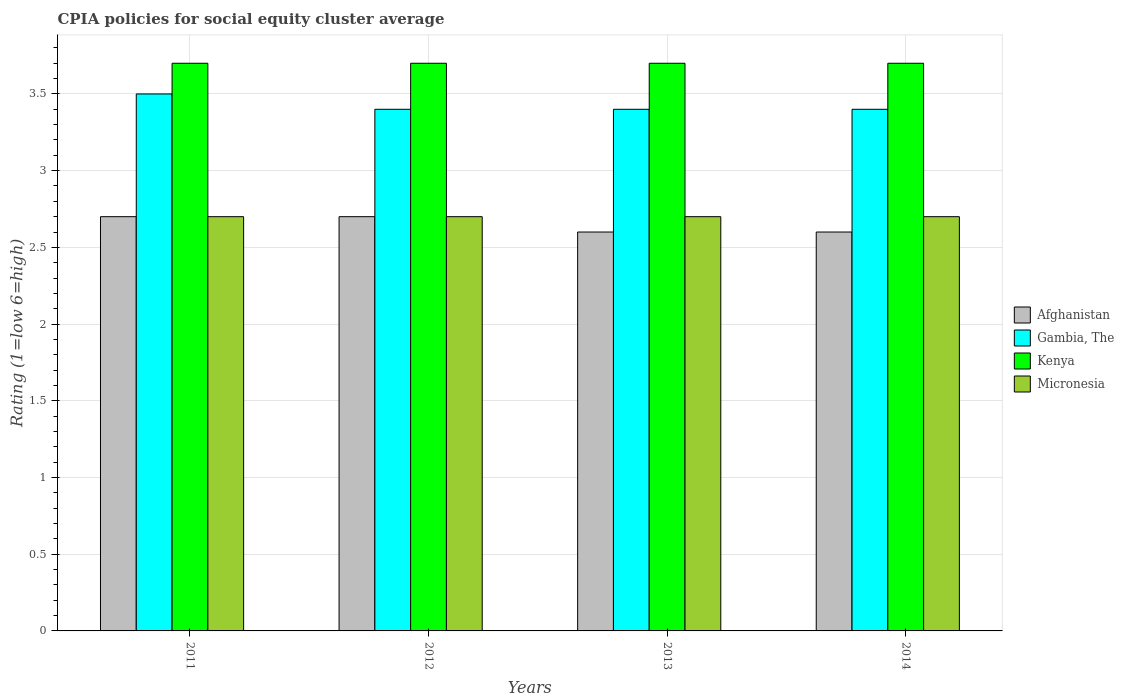How many different coloured bars are there?
Give a very brief answer. 4. How many groups of bars are there?
Provide a short and direct response. 4. How many bars are there on the 2nd tick from the left?
Ensure brevity in your answer.  4. In how many cases, is the number of bars for a given year not equal to the number of legend labels?
Provide a short and direct response. 0. Across all years, what is the maximum CPIA rating in Afghanistan?
Your response must be concise. 2.7. In which year was the CPIA rating in Micronesia maximum?
Provide a short and direct response. 2011. What is the difference between the CPIA rating in Kenya in 2012 and that in 2014?
Ensure brevity in your answer.  0. What is the difference between the CPIA rating in Micronesia in 2011 and the CPIA rating in Afghanistan in 2014?
Provide a succinct answer. 0.1. What is the average CPIA rating in Kenya per year?
Keep it short and to the point. 3.7. In the year 2011, what is the difference between the CPIA rating in Gambia, The and CPIA rating in Kenya?
Give a very brief answer. -0.2. Is the CPIA rating in Gambia, The in 2012 less than that in 2014?
Provide a succinct answer. No. Is the difference between the CPIA rating in Gambia, The in 2011 and 2013 greater than the difference between the CPIA rating in Kenya in 2011 and 2013?
Provide a short and direct response. Yes. What is the difference between the highest and the second highest CPIA rating in Kenya?
Provide a short and direct response. 0. What is the difference between the highest and the lowest CPIA rating in Gambia, The?
Offer a very short reply. 0.1. Is the sum of the CPIA rating in Afghanistan in 2012 and 2013 greater than the maximum CPIA rating in Micronesia across all years?
Your response must be concise. Yes. Is it the case that in every year, the sum of the CPIA rating in Kenya and CPIA rating in Gambia, The is greater than the sum of CPIA rating in Afghanistan and CPIA rating in Micronesia?
Your response must be concise. No. What does the 3rd bar from the left in 2011 represents?
Offer a very short reply. Kenya. What does the 2nd bar from the right in 2012 represents?
Offer a very short reply. Kenya. Is it the case that in every year, the sum of the CPIA rating in Afghanistan and CPIA rating in Gambia, The is greater than the CPIA rating in Kenya?
Provide a succinct answer. Yes. Are all the bars in the graph horizontal?
Give a very brief answer. No. How many years are there in the graph?
Give a very brief answer. 4. What is the difference between two consecutive major ticks on the Y-axis?
Keep it short and to the point. 0.5. Are the values on the major ticks of Y-axis written in scientific E-notation?
Make the answer very short. No. Does the graph contain any zero values?
Your answer should be compact. No. What is the title of the graph?
Provide a succinct answer. CPIA policies for social equity cluster average. Does "Ghana" appear as one of the legend labels in the graph?
Provide a short and direct response. No. What is the label or title of the X-axis?
Make the answer very short. Years. What is the label or title of the Y-axis?
Your answer should be very brief. Rating (1=low 6=high). What is the Rating (1=low 6=high) of Gambia, The in 2011?
Make the answer very short. 3.5. What is the Rating (1=low 6=high) in Kenya in 2011?
Your answer should be very brief. 3.7. What is the Rating (1=low 6=high) in Micronesia in 2011?
Provide a succinct answer. 2.7. What is the Rating (1=low 6=high) in Kenya in 2012?
Make the answer very short. 3.7. What is the Rating (1=low 6=high) of Afghanistan in 2013?
Make the answer very short. 2.6. What is the Rating (1=low 6=high) of Gambia, The in 2013?
Provide a succinct answer. 3.4. What is the Rating (1=low 6=high) of Kenya in 2013?
Provide a succinct answer. 3.7. What is the Rating (1=low 6=high) of Micronesia in 2013?
Provide a short and direct response. 2.7. What is the Rating (1=low 6=high) of Gambia, The in 2014?
Provide a short and direct response. 3.4. What is the Rating (1=low 6=high) of Micronesia in 2014?
Your answer should be compact. 2.7. Across all years, what is the maximum Rating (1=low 6=high) of Gambia, The?
Your response must be concise. 3.5. Across all years, what is the minimum Rating (1=low 6=high) in Gambia, The?
Ensure brevity in your answer.  3.4. Across all years, what is the minimum Rating (1=low 6=high) of Kenya?
Your response must be concise. 3.7. Across all years, what is the minimum Rating (1=low 6=high) in Micronesia?
Your answer should be very brief. 2.7. What is the total Rating (1=low 6=high) of Kenya in the graph?
Your answer should be very brief. 14.8. What is the total Rating (1=low 6=high) of Micronesia in the graph?
Your answer should be compact. 10.8. What is the difference between the Rating (1=low 6=high) in Afghanistan in 2011 and that in 2012?
Make the answer very short. 0. What is the difference between the Rating (1=low 6=high) of Afghanistan in 2011 and that in 2013?
Make the answer very short. 0.1. What is the difference between the Rating (1=low 6=high) in Gambia, The in 2011 and that in 2013?
Offer a terse response. 0.1. What is the difference between the Rating (1=low 6=high) of Afghanistan in 2011 and that in 2014?
Offer a terse response. 0.1. What is the difference between the Rating (1=low 6=high) of Gambia, The in 2011 and that in 2014?
Provide a short and direct response. 0.1. What is the difference between the Rating (1=low 6=high) in Gambia, The in 2012 and that in 2013?
Ensure brevity in your answer.  0. What is the difference between the Rating (1=low 6=high) in Kenya in 2012 and that in 2013?
Your answer should be compact. 0. What is the difference between the Rating (1=low 6=high) of Micronesia in 2012 and that in 2014?
Provide a succinct answer. 0. What is the difference between the Rating (1=low 6=high) of Gambia, The in 2013 and that in 2014?
Offer a very short reply. 0. What is the difference between the Rating (1=low 6=high) of Kenya in 2013 and that in 2014?
Offer a very short reply. 0. What is the difference between the Rating (1=low 6=high) of Micronesia in 2013 and that in 2014?
Offer a very short reply. 0. What is the difference between the Rating (1=low 6=high) in Afghanistan in 2011 and the Rating (1=low 6=high) in Kenya in 2012?
Provide a short and direct response. -1. What is the difference between the Rating (1=low 6=high) of Afghanistan in 2011 and the Rating (1=low 6=high) of Micronesia in 2012?
Ensure brevity in your answer.  0. What is the difference between the Rating (1=low 6=high) of Afghanistan in 2011 and the Rating (1=low 6=high) of Kenya in 2013?
Offer a terse response. -1. What is the difference between the Rating (1=low 6=high) in Afghanistan in 2011 and the Rating (1=low 6=high) in Micronesia in 2014?
Your answer should be very brief. 0. What is the difference between the Rating (1=low 6=high) in Afghanistan in 2012 and the Rating (1=low 6=high) in Gambia, The in 2013?
Give a very brief answer. -0.7. What is the difference between the Rating (1=low 6=high) in Afghanistan in 2012 and the Rating (1=low 6=high) in Micronesia in 2013?
Offer a very short reply. 0. What is the difference between the Rating (1=low 6=high) of Gambia, The in 2012 and the Rating (1=low 6=high) of Micronesia in 2013?
Your answer should be very brief. 0.7. What is the difference between the Rating (1=low 6=high) in Kenya in 2012 and the Rating (1=low 6=high) in Micronesia in 2013?
Your answer should be very brief. 1. What is the difference between the Rating (1=low 6=high) in Afghanistan in 2012 and the Rating (1=low 6=high) in Gambia, The in 2014?
Your answer should be compact. -0.7. What is the difference between the Rating (1=low 6=high) of Afghanistan in 2012 and the Rating (1=low 6=high) of Micronesia in 2014?
Provide a short and direct response. 0. What is the difference between the Rating (1=low 6=high) of Gambia, The in 2012 and the Rating (1=low 6=high) of Micronesia in 2014?
Ensure brevity in your answer.  0.7. What is the difference between the Rating (1=low 6=high) of Kenya in 2012 and the Rating (1=low 6=high) of Micronesia in 2014?
Your answer should be very brief. 1. What is the difference between the Rating (1=low 6=high) in Afghanistan in 2013 and the Rating (1=low 6=high) in Kenya in 2014?
Provide a succinct answer. -1.1. What is the difference between the Rating (1=low 6=high) of Gambia, The in 2013 and the Rating (1=low 6=high) of Micronesia in 2014?
Give a very brief answer. 0.7. What is the difference between the Rating (1=low 6=high) in Kenya in 2013 and the Rating (1=low 6=high) in Micronesia in 2014?
Give a very brief answer. 1. What is the average Rating (1=low 6=high) in Afghanistan per year?
Your answer should be compact. 2.65. What is the average Rating (1=low 6=high) in Gambia, The per year?
Ensure brevity in your answer.  3.42. What is the average Rating (1=low 6=high) of Micronesia per year?
Provide a succinct answer. 2.7. In the year 2011, what is the difference between the Rating (1=low 6=high) in Afghanistan and Rating (1=low 6=high) in Kenya?
Ensure brevity in your answer.  -1. In the year 2012, what is the difference between the Rating (1=low 6=high) in Afghanistan and Rating (1=low 6=high) in Kenya?
Provide a succinct answer. -1. In the year 2012, what is the difference between the Rating (1=low 6=high) in Afghanistan and Rating (1=low 6=high) in Micronesia?
Offer a very short reply. 0. In the year 2012, what is the difference between the Rating (1=low 6=high) of Kenya and Rating (1=low 6=high) of Micronesia?
Ensure brevity in your answer.  1. In the year 2013, what is the difference between the Rating (1=low 6=high) of Afghanistan and Rating (1=low 6=high) of Micronesia?
Make the answer very short. -0.1. In the year 2013, what is the difference between the Rating (1=low 6=high) in Gambia, The and Rating (1=low 6=high) in Micronesia?
Your answer should be very brief. 0.7. In the year 2014, what is the difference between the Rating (1=low 6=high) in Afghanistan and Rating (1=low 6=high) in Micronesia?
Offer a very short reply. -0.1. In the year 2014, what is the difference between the Rating (1=low 6=high) in Gambia, The and Rating (1=low 6=high) in Kenya?
Offer a very short reply. -0.3. In the year 2014, what is the difference between the Rating (1=low 6=high) in Kenya and Rating (1=low 6=high) in Micronesia?
Ensure brevity in your answer.  1. What is the ratio of the Rating (1=low 6=high) of Afghanistan in 2011 to that in 2012?
Your response must be concise. 1. What is the ratio of the Rating (1=low 6=high) in Gambia, The in 2011 to that in 2012?
Provide a succinct answer. 1.03. What is the ratio of the Rating (1=low 6=high) of Afghanistan in 2011 to that in 2013?
Offer a terse response. 1.04. What is the ratio of the Rating (1=low 6=high) in Gambia, The in 2011 to that in 2013?
Keep it short and to the point. 1.03. What is the ratio of the Rating (1=low 6=high) in Micronesia in 2011 to that in 2013?
Provide a succinct answer. 1. What is the ratio of the Rating (1=low 6=high) in Afghanistan in 2011 to that in 2014?
Provide a short and direct response. 1.04. What is the ratio of the Rating (1=low 6=high) of Gambia, The in 2011 to that in 2014?
Your answer should be compact. 1.03. What is the ratio of the Rating (1=low 6=high) in Gambia, The in 2012 to that in 2013?
Provide a short and direct response. 1. What is the ratio of the Rating (1=low 6=high) in Kenya in 2012 to that in 2013?
Offer a very short reply. 1. What is the ratio of the Rating (1=low 6=high) in Micronesia in 2012 to that in 2013?
Offer a terse response. 1. What is the ratio of the Rating (1=low 6=high) of Afghanistan in 2012 to that in 2014?
Your response must be concise. 1.04. What is the ratio of the Rating (1=low 6=high) of Micronesia in 2012 to that in 2014?
Your answer should be very brief. 1. What is the ratio of the Rating (1=low 6=high) in Afghanistan in 2013 to that in 2014?
Make the answer very short. 1. What is the difference between the highest and the second highest Rating (1=low 6=high) in Afghanistan?
Keep it short and to the point. 0. What is the difference between the highest and the second highest Rating (1=low 6=high) in Gambia, The?
Give a very brief answer. 0.1. What is the difference between the highest and the second highest Rating (1=low 6=high) of Kenya?
Provide a succinct answer. 0. What is the difference between the highest and the second highest Rating (1=low 6=high) of Micronesia?
Your response must be concise. 0. What is the difference between the highest and the lowest Rating (1=low 6=high) of Afghanistan?
Your response must be concise. 0.1. What is the difference between the highest and the lowest Rating (1=low 6=high) of Gambia, The?
Offer a terse response. 0.1. 